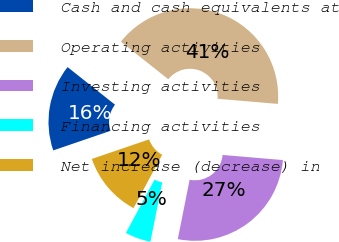Convert chart to OTSL. <chart><loc_0><loc_0><loc_500><loc_500><pie_chart><fcel>Cash and cash equivalents at<fcel>Operating activities<fcel>Investing activities<fcel>Financing activities<fcel>Net increase (decrease) in<nl><fcel>15.91%<fcel>40.68%<fcel>26.78%<fcel>4.72%<fcel>11.91%<nl></chart> 